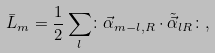<formula> <loc_0><loc_0><loc_500><loc_500>\bar { L } _ { m } = \frac { 1 } { 2 } \sum _ { l } \colon \vec { \alpha } _ { m - l , R } \cdot \tilde { \vec { \alpha } } _ { l R } \colon ,</formula> 